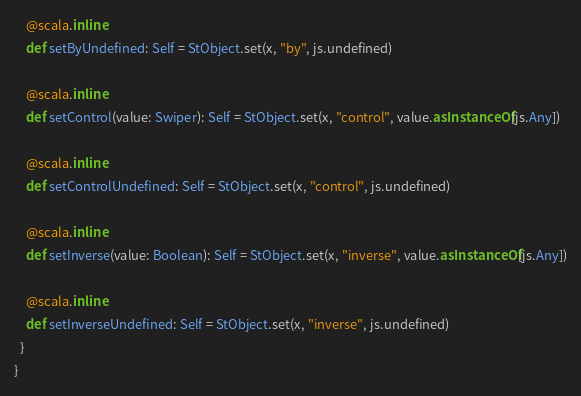<code> <loc_0><loc_0><loc_500><loc_500><_Scala_>    @scala.inline
    def setByUndefined: Self = StObject.set(x, "by", js.undefined)
    
    @scala.inline
    def setControl(value: Swiper): Self = StObject.set(x, "control", value.asInstanceOf[js.Any])
    
    @scala.inline
    def setControlUndefined: Self = StObject.set(x, "control", js.undefined)
    
    @scala.inline
    def setInverse(value: Boolean): Self = StObject.set(x, "inverse", value.asInstanceOf[js.Any])
    
    @scala.inline
    def setInverseUndefined: Self = StObject.set(x, "inverse", js.undefined)
  }
}
</code> 